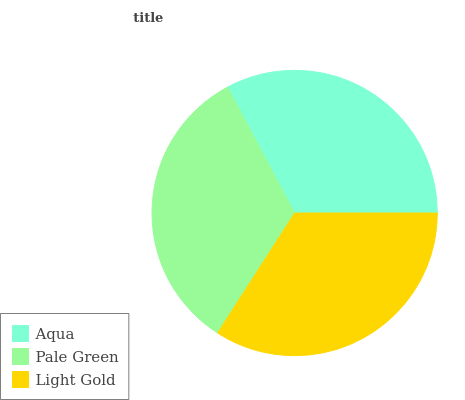Is Aqua the minimum?
Answer yes or no. Yes. Is Light Gold the maximum?
Answer yes or no. Yes. Is Pale Green the minimum?
Answer yes or no. No. Is Pale Green the maximum?
Answer yes or no. No. Is Pale Green greater than Aqua?
Answer yes or no. Yes. Is Aqua less than Pale Green?
Answer yes or no. Yes. Is Aqua greater than Pale Green?
Answer yes or no. No. Is Pale Green less than Aqua?
Answer yes or no. No. Is Pale Green the high median?
Answer yes or no. Yes. Is Pale Green the low median?
Answer yes or no. Yes. Is Aqua the high median?
Answer yes or no. No. Is Aqua the low median?
Answer yes or no. No. 